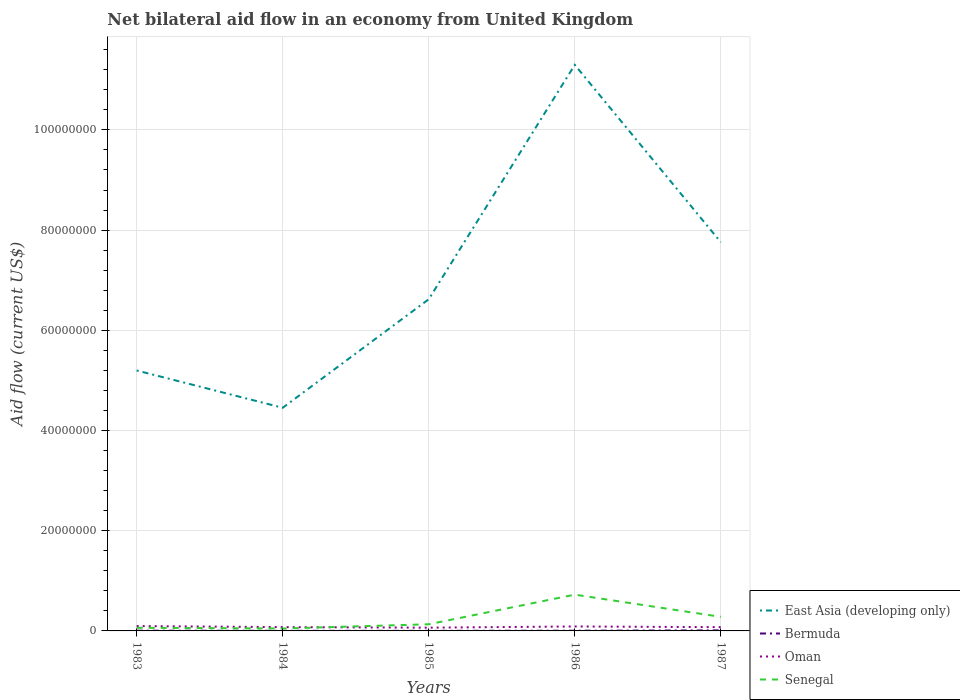Is the number of lines equal to the number of legend labels?
Give a very brief answer. Yes. Across all years, what is the maximum net bilateral aid flow in Oman?
Provide a short and direct response. 6.50e+05. In which year was the net bilateral aid flow in East Asia (developing only) maximum?
Keep it short and to the point. 1984. What is the difference between the highest and the second highest net bilateral aid flow in Bermuda?
Offer a very short reply. 9.00e+04. How many lines are there?
Offer a terse response. 4. What is the difference between two consecutive major ticks on the Y-axis?
Offer a terse response. 2.00e+07. Are the values on the major ticks of Y-axis written in scientific E-notation?
Offer a terse response. No. Where does the legend appear in the graph?
Your answer should be very brief. Bottom right. How many legend labels are there?
Your answer should be compact. 4. What is the title of the graph?
Provide a short and direct response. Net bilateral aid flow in an economy from United Kingdom. Does "Italy" appear as one of the legend labels in the graph?
Provide a succinct answer. No. What is the Aid flow (current US$) of East Asia (developing only) in 1983?
Provide a short and direct response. 5.20e+07. What is the Aid flow (current US$) in Bermuda in 1983?
Offer a terse response. 5.00e+04. What is the Aid flow (current US$) of Oman in 1983?
Offer a terse response. 9.70e+05. What is the Aid flow (current US$) in Senegal in 1983?
Make the answer very short. 6.30e+05. What is the Aid flow (current US$) in East Asia (developing only) in 1984?
Ensure brevity in your answer.  4.45e+07. What is the Aid flow (current US$) of Oman in 1984?
Offer a terse response. 7.60e+05. What is the Aid flow (current US$) of East Asia (developing only) in 1985?
Your response must be concise. 6.62e+07. What is the Aid flow (current US$) of Oman in 1985?
Make the answer very short. 6.50e+05. What is the Aid flow (current US$) in Senegal in 1985?
Your response must be concise. 1.33e+06. What is the Aid flow (current US$) in East Asia (developing only) in 1986?
Provide a short and direct response. 1.13e+08. What is the Aid flow (current US$) of Bermuda in 1986?
Offer a very short reply. 4.00e+04. What is the Aid flow (current US$) of Oman in 1986?
Give a very brief answer. 8.90e+05. What is the Aid flow (current US$) in Senegal in 1986?
Provide a succinct answer. 7.24e+06. What is the Aid flow (current US$) of East Asia (developing only) in 1987?
Give a very brief answer. 7.76e+07. What is the Aid flow (current US$) of Oman in 1987?
Offer a very short reply. 7.50e+05. What is the Aid flow (current US$) in Senegal in 1987?
Your response must be concise. 2.81e+06. Across all years, what is the maximum Aid flow (current US$) in East Asia (developing only)?
Your answer should be compact. 1.13e+08. Across all years, what is the maximum Aid flow (current US$) of Bermuda?
Make the answer very short. 1.10e+05. Across all years, what is the maximum Aid flow (current US$) in Oman?
Give a very brief answer. 9.70e+05. Across all years, what is the maximum Aid flow (current US$) in Senegal?
Your response must be concise. 7.24e+06. Across all years, what is the minimum Aid flow (current US$) in East Asia (developing only)?
Your answer should be compact. 4.45e+07. Across all years, what is the minimum Aid flow (current US$) in Oman?
Make the answer very short. 6.50e+05. Across all years, what is the minimum Aid flow (current US$) of Senegal?
Offer a very short reply. 4.80e+05. What is the total Aid flow (current US$) in East Asia (developing only) in the graph?
Provide a succinct answer. 3.53e+08. What is the total Aid flow (current US$) in Oman in the graph?
Provide a short and direct response. 4.02e+06. What is the total Aid flow (current US$) in Senegal in the graph?
Give a very brief answer. 1.25e+07. What is the difference between the Aid flow (current US$) of East Asia (developing only) in 1983 and that in 1984?
Provide a succinct answer. 7.44e+06. What is the difference between the Aid flow (current US$) in East Asia (developing only) in 1983 and that in 1985?
Offer a very short reply. -1.42e+07. What is the difference between the Aid flow (current US$) in Senegal in 1983 and that in 1985?
Provide a short and direct response. -7.00e+05. What is the difference between the Aid flow (current US$) of East Asia (developing only) in 1983 and that in 1986?
Keep it short and to the point. -6.10e+07. What is the difference between the Aid flow (current US$) of Senegal in 1983 and that in 1986?
Your response must be concise. -6.61e+06. What is the difference between the Aid flow (current US$) of East Asia (developing only) in 1983 and that in 1987?
Keep it short and to the point. -2.56e+07. What is the difference between the Aid flow (current US$) of Senegal in 1983 and that in 1987?
Keep it short and to the point. -2.18e+06. What is the difference between the Aid flow (current US$) in East Asia (developing only) in 1984 and that in 1985?
Offer a very short reply. -2.17e+07. What is the difference between the Aid flow (current US$) in Bermuda in 1984 and that in 1985?
Provide a succinct answer. 0. What is the difference between the Aid flow (current US$) in Senegal in 1984 and that in 1985?
Give a very brief answer. -8.50e+05. What is the difference between the Aid flow (current US$) in East Asia (developing only) in 1984 and that in 1986?
Offer a terse response. -6.84e+07. What is the difference between the Aid flow (current US$) of Oman in 1984 and that in 1986?
Give a very brief answer. -1.30e+05. What is the difference between the Aid flow (current US$) in Senegal in 1984 and that in 1986?
Make the answer very short. -6.76e+06. What is the difference between the Aid flow (current US$) in East Asia (developing only) in 1984 and that in 1987?
Make the answer very short. -3.30e+07. What is the difference between the Aid flow (current US$) of Senegal in 1984 and that in 1987?
Provide a short and direct response. -2.33e+06. What is the difference between the Aid flow (current US$) in East Asia (developing only) in 1985 and that in 1986?
Make the answer very short. -4.68e+07. What is the difference between the Aid flow (current US$) of Bermuda in 1985 and that in 1986?
Your response must be concise. -2.00e+04. What is the difference between the Aid flow (current US$) in Oman in 1985 and that in 1986?
Your answer should be very brief. -2.40e+05. What is the difference between the Aid flow (current US$) of Senegal in 1985 and that in 1986?
Offer a terse response. -5.91e+06. What is the difference between the Aid flow (current US$) of East Asia (developing only) in 1985 and that in 1987?
Your answer should be compact. -1.14e+07. What is the difference between the Aid flow (current US$) of Senegal in 1985 and that in 1987?
Offer a very short reply. -1.48e+06. What is the difference between the Aid flow (current US$) of East Asia (developing only) in 1986 and that in 1987?
Give a very brief answer. 3.54e+07. What is the difference between the Aid flow (current US$) of Bermuda in 1986 and that in 1987?
Provide a short and direct response. -7.00e+04. What is the difference between the Aid flow (current US$) in Oman in 1986 and that in 1987?
Make the answer very short. 1.40e+05. What is the difference between the Aid flow (current US$) in Senegal in 1986 and that in 1987?
Offer a very short reply. 4.43e+06. What is the difference between the Aid flow (current US$) of East Asia (developing only) in 1983 and the Aid flow (current US$) of Bermuda in 1984?
Ensure brevity in your answer.  5.20e+07. What is the difference between the Aid flow (current US$) of East Asia (developing only) in 1983 and the Aid flow (current US$) of Oman in 1984?
Offer a very short reply. 5.12e+07. What is the difference between the Aid flow (current US$) in East Asia (developing only) in 1983 and the Aid flow (current US$) in Senegal in 1984?
Offer a very short reply. 5.15e+07. What is the difference between the Aid flow (current US$) in Bermuda in 1983 and the Aid flow (current US$) in Oman in 1984?
Your answer should be very brief. -7.10e+05. What is the difference between the Aid flow (current US$) of Bermuda in 1983 and the Aid flow (current US$) of Senegal in 1984?
Provide a short and direct response. -4.30e+05. What is the difference between the Aid flow (current US$) in East Asia (developing only) in 1983 and the Aid flow (current US$) in Bermuda in 1985?
Offer a terse response. 5.20e+07. What is the difference between the Aid flow (current US$) of East Asia (developing only) in 1983 and the Aid flow (current US$) of Oman in 1985?
Ensure brevity in your answer.  5.13e+07. What is the difference between the Aid flow (current US$) of East Asia (developing only) in 1983 and the Aid flow (current US$) of Senegal in 1985?
Provide a succinct answer. 5.06e+07. What is the difference between the Aid flow (current US$) in Bermuda in 1983 and the Aid flow (current US$) in Oman in 1985?
Ensure brevity in your answer.  -6.00e+05. What is the difference between the Aid flow (current US$) in Bermuda in 1983 and the Aid flow (current US$) in Senegal in 1985?
Offer a terse response. -1.28e+06. What is the difference between the Aid flow (current US$) in Oman in 1983 and the Aid flow (current US$) in Senegal in 1985?
Ensure brevity in your answer.  -3.60e+05. What is the difference between the Aid flow (current US$) in East Asia (developing only) in 1983 and the Aid flow (current US$) in Bermuda in 1986?
Keep it short and to the point. 5.19e+07. What is the difference between the Aid flow (current US$) of East Asia (developing only) in 1983 and the Aid flow (current US$) of Oman in 1986?
Your answer should be very brief. 5.11e+07. What is the difference between the Aid flow (current US$) in East Asia (developing only) in 1983 and the Aid flow (current US$) in Senegal in 1986?
Your answer should be compact. 4.47e+07. What is the difference between the Aid flow (current US$) in Bermuda in 1983 and the Aid flow (current US$) in Oman in 1986?
Your response must be concise. -8.40e+05. What is the difference between the Aid flow (current US$) of Bermuda in 1983 and the Aid flow (current US$) of Senegal in 1986?
Make the answer very short. -7.19e+06. What is the difference between the Aid flow (current US$) of Oman in 1983 and the Aid flow (current US$) of Senegal in 1986?
Ensure brevity in your answer.  -6.27e+06. What is the difference between the Aid flow (current US$) of East Asia (developing only) in 1983 and the Aid flow (current US$) of Bermuda in 1987?
Offer a terse response. 5.19e+07. What is the difference between the Aid flow (current US$) of East Asia (developing only) in 1983 and the Aid flow (current US$) of Oman in 1987?
Give a very brief answer. 5.12e+07. What is the difference between the Aid flow (current US$) in East Asia (developing only) in 1983 and the Aid flow (current US$) in Senegal in 1987?
Provide a short and direct response. 4.92e+07. What is the difference between the Aid flow (current US$) of Bermuda in 1983 and the Aid flow (current US$) of Oman in 1987?
Offer a very short reply. -7.00e+05. What is the difference between the Aid flow (current US$) of Bermuda in 1983 and the Aid flow (current US$) of Senegal in 1987?
Offer a very short reply. -2.76e+06. What is the difference between the Aid flow (current US$) in Oman in 1983 and the Aid flow (current US$) in Senegal in 1987?
Your answer should be compact. -1.84e+06. What is the difference between the Aid flow (current US$) in East Asia (developing only) in 1984 and the Aid flow (current US$) in Bermuda in 1985?
Keep it short and to the point. 4.45e+07. What is the difference between the Aid flow (current US$) in East Asia (developing only) in 1984 and the Aid flow (current US$) in Oman in 1985?
Provide a succinct answer. 4.39e+07. What is the difference between the Aid flow (current US$) in East Asia (developing only) in 1984 and the Aid flow (current US$) in Senegal in 1985?
Your response must be concise. 4.32e+07. What is the difference between the Aid flow (current US$) in Bermuda in 1984 and the Aid flow (current US$) in Oman in 1985?
Ensure brevity in your answer.  -6.30e+05. What is the difference between the Aid flow (current US$) of Bermuda in 1984 and the Aid flow (current US$) of Senegal in 1985?
Your answer should be very brief. -1.31e+06. What is the difference between the Aid flow (current US$) in Oman in 1984 and the Aid flow (current US$) in Senegal in 1985?
Provide a succinct answer. -5.70e+05. What is the difference between the Aid flow (current US$) in East Asia (developing only) in 1984 and the Aid flow (current US$) in Bermuda in 1986?
Offer a terse response. 4.45e+07. What is the difference between the Aid flow (current US$) of East Asia (developing only) in 1984 and the Aid flow (current US$) of Oman in 1986?
Offer a terse response. 4.36e+07. What is the difference between the Aid flow (current US$) of East Asia (developing only) in 1984 and the Aid flow (current US$) of Senegal in 1986?
Make the answer very short. 3.73e+07. What is the difference between the Aid flow (current US$) of Bermuda in 1984 and the Aid flow (current US$) of Oman in 1986?
Give a very brief answer. -8.70e+05. What is the difference between the Aid flow (current US$) of Bermuda in 1984 and the Aid flow (current US$) of Senegal in 1986?
Your answer should be compact. -7.22e+06. What is the difference between the Aid flow (current US$) of Oman in 1984 and the Aid flow (current US$) of Senegal in 1986?
Keep it short and to the point. -6.48e+06. What is the difference between the Aid flow (current US$) in East Asia (developing only) in 1984 and the Aid flow (current US$) in Bermuda in 1987?
Provide a short and direct response. 4.44e+07. What is the difference between the Aid flow (current US$) in East Asia (developing only) in 1984 and the Aid flow (current US$) in Oman in 1987?
Give a very brief answer. 4.38e+07. What is the difference between the Aid flow (current US$) of East Asia (developing only) in 1984 and the Aid flow (current US$) of Senegal in 1987?
Offer a terse response. 4.17e+07. What is the difference between the Aid flow (current US$) in Bermuda in 1984 and the Aid flow (current US$) in Oman in 1987?
Ensure brevity in your answer.  -7.30e+05. What is the difference between the Aid flow (current US$) of Bermuda in 1984 and the Aid flow (current US$) of Senegal in 1987?
Provide a succinct answer. -2.79e+06. What is the difference between the Aid flow (current US$) in Oman in 1984 and the Aid flow (current US$) in Senegal in 1987?
Make the answer very short. -2.05e+06. What is the difference between the Aid flow (current US$) in East Asia (developing only) in 1985 and the Aid flow (current US$) in Bermuda in 1986?
Provide a succinct answer. 6.62e+07. What is the difference between the Aid flow (current US$) of East Asia (developing only) in 1985 and the Aid flow (current US$) of Oman in 1986?
Your response must be concise. 6.53e+07. What is the difference between the Aid flow (current US$) of East Asia (developing only) in 1985 and the Aid flow (current US$) of Senegal in 1986?
Your response must be concise. 5.90e+07. What is the difference between the Aid flow (current US$) in Bermuda in 1985 and the Aid flow (current US$) in Oman in 1986?
Provide a succinct answer. -8.70e+05. What is the difference between the Aid flow (current US$) in Bermuda in 1985 and the Aid flow (current US$) in Senegal in 1986?
Your answer should be very brief. -7.22e+06. What is the difference between the Aid flow (current US$) of Oman in 1985 and the Aid flow (current US$) of Senegal in 1986?
Provide a short and direct response. -6.59e+06. What is the difference between the Aid flow (current US$) of East Asia (developing only) in 1985 and the Aid flow (current US$) of Bermuda in 1987?
Your answer should be compact. 6.61e+07. What is the difference between the Aid flow (current US$) in East Asia (developing only) in 1985 and the Aid flow (current US$) in Oman in 1987?
Provide a succinct answer. 6.54e+07. What is the difference between the Aid flow (current US$) in East Asia (developing only) in 1985 and the Aid flow (current US$) in Senegal in 1987?
Offer a very short reply. 6.34e+07. What is the difference between the Aid flow (current US$) of Bermuda in 1985 and the Aid flow (current US$) of Oman in 1987?
Offer a very short reply. -7.30e+05. What is the difference between the Aid flow (current US$) of Bermuda in 1985 and the Aid flow (current US$) of Senegal in 1987?
Give a very brief answer. -2.79e+06. What is the difference between the Aid flow (current US$) of Oman in 1985 and the Aid flow (current US$) of Senegal in 1987?
Offer a terse response. -2.16e+06. What is the difference between the Aid flow (current US$) of East Asia (developing only) in 1986 and the Aid flow (current US$) of Bermuda in 1987?
Offer a terse response. 1.13e+08. What is the difference between the Aid flow (current US$) in East Asia (developing only) in 1986 and the Aid flow (current US$) in Oman in 1987?
Keep it short and to the point. 1.12e+08. What is the difference between the Aid flow (current US$) of East Asia (developing only) in 1986 and the Aid flow (current US$) of Senegal in 1987?
Offer a very short reply. 1.10e+08. What is the difference between the Aid flow (current US$) in Bermuda in 1986 and the Aid flow (current US$) in Oman in 1987?
Keep it short and to the point. -7.10e+05. What is the difference between the Aid flow (current US$) in Bermuda in 1986 and the Aid flow (current US$) in Senegal in 1987?
Make the answer very short. -2.77e+06. What is the difference between the Aid flow (current US$) of Oman in 1986 and the Aid flow (current US$) of Senegal in 1987?
Offer a terse response. -1.92e+06. What is the average Aid flow (current US$) of East Asia (developing only) per year?
Provide a succinct answer. 7.07e+07. What is the average Aid flow (current US$) in Bermuda per year?
Your answer should be compact. 4.80e+04. What is the average Aid flow (current US$) in Oman per year?
Provide a short and direct response. 8.04e+05. What is the average Aid flow (current US$) of Senegal per year?
Provide a succinct answer. 2.50e+06. In the year 1983, what is the difference between the Aid flow (current US$) in East Asia (developing only) and Aid flow (current US$) in Bermuda?
Keep it short and to the point. 5.19e+07. In the year 1983, what is the difference between the Aid flow (current US$) of East Asia (developing only) and Aid flow (current US$) of Oman?
Your response must be concise. 5.10e+07. In the year 1983, what is the difference between the Aid flow (current US$) in East Asia (developing only) and Aid flow (current US$) in Senegal?
Make the answer very short. 5.14e+07. In the year 1983, what is the difference between the Aid flow (current US$) in Bermuda and Aid flow (current US$) in Oman?
Offer a terse response. -9.20e+05. In the year 1983, what is the difference between the Aid flow (current US$) of Bermuda and Aid flow (current US$) of Senegal?
Give a very brief answer. -5.80e+05. In the year 1984, what is the difference between the Aid flow (current US$) of East Asia (developing only) and Aid flow (current US$) of Bermuda?
Keep it short and to the point. 4.45e+07. In the year 1984, what is the difference between the Aid flow (current US$) in East Asia (developing only) and Aid flow (current US$) in Oman?
Offer a terse response. 4.38e+07. In the year 1984, what is the difference between the Aid flow (current US$) in East Asia (developing only) and Aid flow (current US$) in Senegal?
Provide a short and direct response. 4.41e+07. In the year 1984, what is the difference between the Aid flow (current US$) of Bermuda and Aid flow (current US$) of Oman?
Provide a short and direct response. -7.40e+05. In the year 1984, what is the difference between the Aid flow (current US$) in Bermuda and Aid flow (current US$) in Senegal?
Your answer should be compact. -4.60e+05. In the year 1985, what is the difference between the Aid flow (current US$) in East Asia (developing only) and Aid flow (current US$) in Bermuda?
Offer a very short reply. 6.62e+07. In the year 1985, what is the difference between the Aid flow (current US$) of East Asia (developing only) and Aid flow (current US$) of Oman?
Your response must be concise. 6.56e+07. In the year 1985, what is the difference between the Aid flow (current US$) in East Asia (developing only) and Aid flow (current US$) in Senegal?
Your answer should be compact. 6.49e+07. In the year 1985, what is the difference between the Aid flow (current US$) of Bermuda and Aid flow (current US$) of Oman?
Provide a succinct answer. -6.30e+05. In the year 1985, what is the difference between the Aid flow (current US$) in Bermuda and Aid flow (current US$) in Senegal?
Keep it short and to the point. -1.31e+06. In the year 1985, what is the difference between the Aid flow (current US$) in Oman and Aid flow (current US$) in Senegal?
Give a very brief answer. -6.80e+05. In the year 1986, what is the difference between the Aid flow (current US$) in East Asia (developing only) and Aid flow (current US$) in Bermuda?
Offer a very short reply. 1.13e+08. In the year 1986, what is the difference between the Aid flow (current US$) in East Asia (developing only) and Aid flow (current US$) in Oman?
Your response must be concise. 1.12e+08. In the year 1986, what is the difference between the Aid flow (current US$) in East Asia (developing only) and Aid flow (current US$) in Senegal?
Give a very brief answer. 1.06e+08. In the year 1986, what is the difference between the Aid flow (current US$) of Bermuda and Aid flow (current US$) of Oman?
Keep it short and to the point. -8.50e+05. In the year 1986, what is the difference between the Aid flow (current US$) in Bermuda and Aid flow (current US$) in Senegal?
Keep it short and to the point. -7.20e+06. In the year 1986, what is the difference between the Aid flow (current US$) in Oman and Aid flow (current US$) in Senegal?
Ensure brevity in your answer.  -6.35e+06. In the year 1987, what is the difference between the Aid flow (current US$) in East Asia (developing only) and Aid flow (current US$) in Bermuda?
Offer a very short reply. 7.75e+07. In the year 1987, what is the difference between the Aid flow (current US$) in East Asia (developing only) and Aid flow (current US$) in Oman?
Your answer should be very brief. 7.68e+07. In the year 1987, what is the difference between the Aid flow (current US$) of East Asia (developing only) and Aid flow (current US$) of Senegal?
Offer a terse response. 7.48e+07. In the year 1987, what is the difference between the Aid flow (current US$) of Bermuda and Aid flow (current US$) of Oman?
Offer a terse response. -6.40e+05. In the year 1987, what is the difference between the Aid flow (current US$) in Bermuda and Aid flow (current US$) in Senegal?
Keep it short and to the point. -2.70e+06. In the year 1987, what is the difference between the Aid flow (current US$) of Oman and Aid flow (current US$) of Senegal?
Give a very brief answer. -2.06e+06. What is the ratio of the Aid flow (current US$) of East Asia (developing only) in 1983 to that in 1984?
Your response must be concise. 1.17. What is the ratio of the Aid flow (current US$) in Oman in 1983 to that in 1984?
Your answer should be compact. 1.28. What is the ratio of the Aid flow (current US$) in Senegal in 1983 to that in 1984?
Offer a very short reply. 1.31. What is the ratio of the Aid flow (current US$) in East Asia (developing only) in 1983 to that in 1985?
Offer a terse response. 0.79. What is the ratio of the Aid flow (current US$) in Bermuda in 1983 to that in 1985?
Keep it short and to the point. 2.5. What is the ratio of the Aid flow (current US$) of Oman in 1983 to that in 1985?
Give a very brief answer. 1.49. What is the ratio of the Aid flow (current US$) of Senegal in 1983 to that in 1985?
Offer a terse response. 0.47. What is the ratio of the Aid flow (current US$) of East Asia (developing only) in 1983 to that in 1986?
Keep it short and to the point. 0.46. What is the ratio of the Aid flow (current US$) of Oman in 1983 to that in 1986?
Offer a terse response. 1.09. What is the ratio of the Aid flow (current US$) in Senegal in 1983 to that in 1986?
Give a very brief answer. 0.09. What is the ratio of the Aid flow (current US$) in East Asia (developing only) in 1983 to that in 1987?
Your answer should be compact. 0.67. What is the ratio of the Aid flow (current US$) of Bermuda in 1983 to that in 1987?
Provide a succinct answer. 0.45. What is the ratio of the Aid flow (current US$) in Oman in 1983 to that in 1987?
Provide a succinct answer. 1.29. What is the ratio of the Aid flow (current US$) of Senegal in 1983 to that in 1987?
Provide a short and direct response. 0.22. What is the ratio of the Aid flow (current US$) in East Asia (developing only) in 1984 to that in 1985?
Provide a succinct answer. 0.67. What is the ratio of the Aid flow (current US$) in Oman in 1984 to that in 1985?
Offer a very short reply. 1.17. What is the ratio of the Aid flow (current US$) of Senegal in 1984 to that in 1985?
Offer a very short reply. 0.36. What is the ratio of the Aid flow (current US$) in East Asia (developing only) in 1984 to that in 1986?
Give a very brief answer. 0.39. What is the ratio of the Aid flow (current US$) of Oman in 1984 to that in 1986?
Give a very brief answer. 0.85. What is the ratio of the Aid flow (current US$) in Senegal in 1984 to that in 1986?
Provide a succinct answer. 0.07. What is the ratio of the Aid flow (current US$) of East Asia (developing only) in 1984 to that in 1987?
Make the answer very short. 0.57. What is the ratio of the Aid flow (current US$) in Bermuda in 1984 to that in 1987?
Your answer should be compact. 0.18. What is the ratio of the Aid flow (current US$) in Oman in 1984 to that in 1987?
Provide a succinct answer. 1.01. What is the ratio of the Aid flow (current US$) in Senegal in 1984 to that in 1987?
Provide a succinct answer. 0.17. What is the ratio of the Aid flow (current US$) in East Asia (developing only) in 1985 to that in 1986?
Your answer should be compact. 0.59. What is the ratio of the Aid flow (current US$) of Bermuda in 1985 to that in 1986?
Provide a succinct answer. 0.5. What is the ratio of the Aid flow (current US$) of Oman in 1985 to that in 1986?
Make the answer very short. 0.73. What is the ratio of the Aid flow (current US$) in Senegal in 1985 to that in 1986?
Make the answer very short. 0.18. What is the ratio of the Aid flow (current US$) of East Asia (developing only) in 1985 to that in 1987?
Your response must be concise. 0.85. What is the ratio of the Aid flow (current US$) of Bermuda in 1985 to that in 1987?
Make the answer very short. 0.18. What is the ratio of the Aid flow (current US$) of Oman in 1985 to that in 1987?
Keep it short and to the point. 0.87. What is the ratio of the Aid flow (current US$) of Senegal in 1985 to that in 1987?
Keep it short and to the point. 0.47. What is the ratio of the Aid flow (current US$) of East Asia (developing only) in 1986 to that in 1987?
Make the answer very short. 1.46. What is the ratio of the Aid flow (current US$) in Bermuda in 1986 to that in 1987?
Your response must be concise. 0.36. What is the ratio of the Aid flow (current US$) of Oman in 1986 to that in 1987?
Keep it short and to the point. 1.19. What is the ratio of the Aid flow (current US$) of Senegal in 1986 to that in 1987?
Provide a short and direct response. 2.58. What is the difference between the highest and the second highest Aid flow (current US$) in East Asia (developing only)?
Make the answer very short. 3.54e+07. What is the difference between the highest and the second highest Aid flow (current US$) in Oman?
Make the answer very short. 8.00e+04. What is the difference between the highest and the second highest Aid flow (current US$) of Senegal?
Make the answer very short. 4.43e+06. What is the difference between the highest and the lowest Aid flow (current US$) in East Asia (developing only)?
Give a very brief answer. 6.84e+07. What is the difference between the highest and the lowest Aid flow (current US$) in Bermuda?
Offer a very short reply. 9.00e+04. What is the difference between the highest and the lowest Aid flow (current US$) of Oman?
Keep it short and to the point. 3.20e+05. What is the difference between the highest and the lowest Aid flow (current US$) of Senegal?
Make the answer very short. 6.76e+06. 